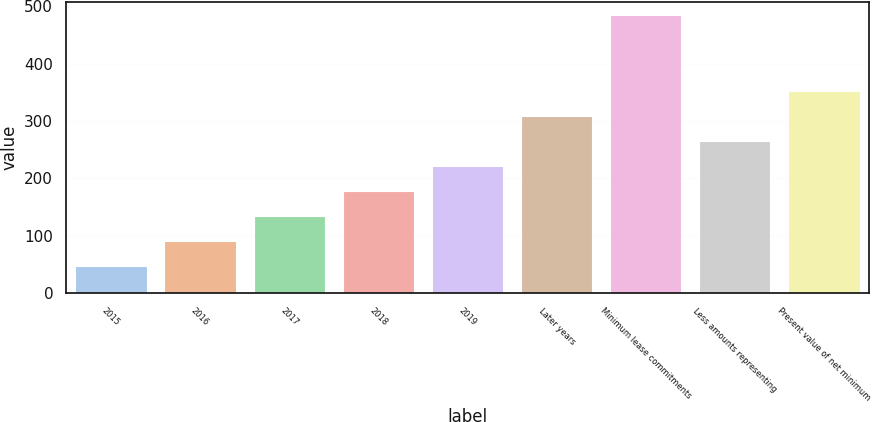Convert chart. <chart><loc_0><loc_0><loc_500><loc_500><bar_chart><fcel>2015<fcel>2016<fcel>2017<fcel>2018<fcel>2019<fcel>Later years<fcel>Minimum lease commitments<fcel>Less amounts representing<fcel>Present value of net minimum<nl><fcel>47<fcel>90.7<fcel>134.4<fcel>178.1<fcel>221.8<fcel>309.2<fcel>484<fcel>265.5<fcel>352.9<nl></chart> 